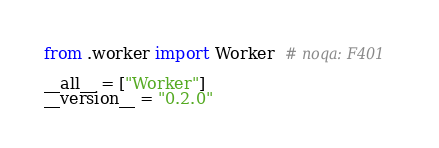<code> <loc_0><loc_0><loc_500><loc_500><_Python_>from .worker import Worker  # noqa: F401

__all__ = ["Worker"]
__version__ = "0.2.0"
</code> 